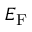<formula> <loc_0><loc_0><loc_500><loc_500>E _ { F }</formula> 